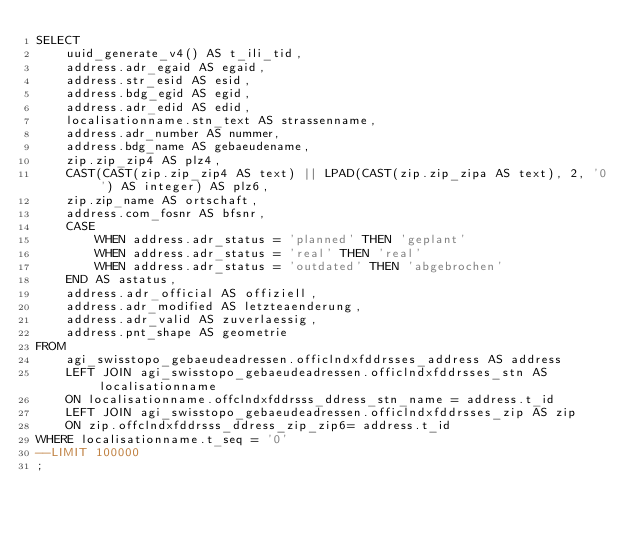<code> <loc_0><loc_0><loc_500><loc_500><_SQL_>SELECT
    uuid_generate_v4() AS t_ili_tid,
    address.adr_egaid AS egaid,
    address.str_esid AS esid,
    address.bdg_egid AS egid,
    address.adr_edid AS edid,
    localisationname.stn_text AS strassenname,
    address.adr_number AS nummer,
    address.bdg_name AS gebaeudename,
    zip.zip_zip4 AS plz4,
    CAST(CAST(zip.zip_zip4 AS text) || LPAD(CAST(zip.zip_zipa AS text), 2, '0') AS integer) AS plz6,
    zip.zip_name AS ortschaft,
    address.com_fosnr AS bfsnr,
    CASE 
        WHEN address.adr_status = 'planned' THEN 'geplant'
        WHEN address.adr_status = 'real' THEN 'real'
        WHEN address.adr_status = 'outdated' THEN 'abgebrochen'
    END AS astatus,
    address.adr_official AS offiziell,
    address.adr_modified AS letzteaenderung,
    address.adr_valid AS zuverlaessig,
    address.pnt_shape AS geometrie
FROM
    agi_swisstopo_gebaeudeadressen.officlndxfddrsses_address AS address
    LEFT JOIN agi_swisstopo_gebaeudeadressen.officlndxfddrsses_stn AS localisationname
    ON localisationname.offclndxfddrsss_ddress_stn_name = address.t_id 
    LEFT JOIN agi_swisstopo_gebaeudeadressen.officlndxfddrsses_zip AS zip
    ON zip.offclndxfddrsss_ddress_zip_zip6= address.t_id 
WHERE localisationname.t_seq = '0'
--LIMIT 100000   
;

</code> 